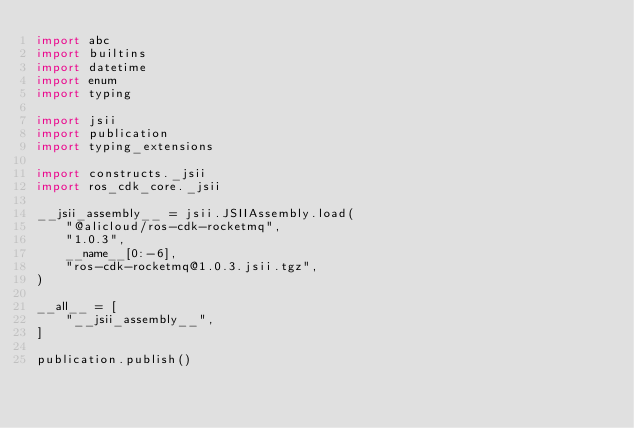Convert code to text. <code><loc_0><loc_0><loc_500><loc_500><_Python_>import abc
import builtins
import datetime
import enum
import typing

import jsii
import publication
import typing_extensions

import constructs._jsii
import ros_cdk_core._jsii

__jsii_assembly__ = jsii.JSIIAssembly.load(
    "@alicloud/ros-cdk-rocketmq",
    "1.0.3",
    __name__[0:-6],
    "ros-cdk-rocketmq@1.0.3.jsii.tgz",
)

__all__ = [
    "__jsii_assembly__",
]

publication.publish()
</code> 